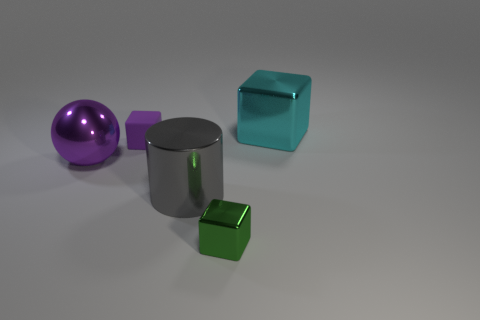How would you describe the lighting and shadows in the scene? The lighting in the scene is soft and diffused, casting gentle, but clearly defined shadows on the ground from each object. The direction of the light source seems to be coming from the upper left, as indicated by the shadow placement. This lighting setup helps to enhance the three-dimensional appearance of the objects and gives a sense of depth to the scene. 